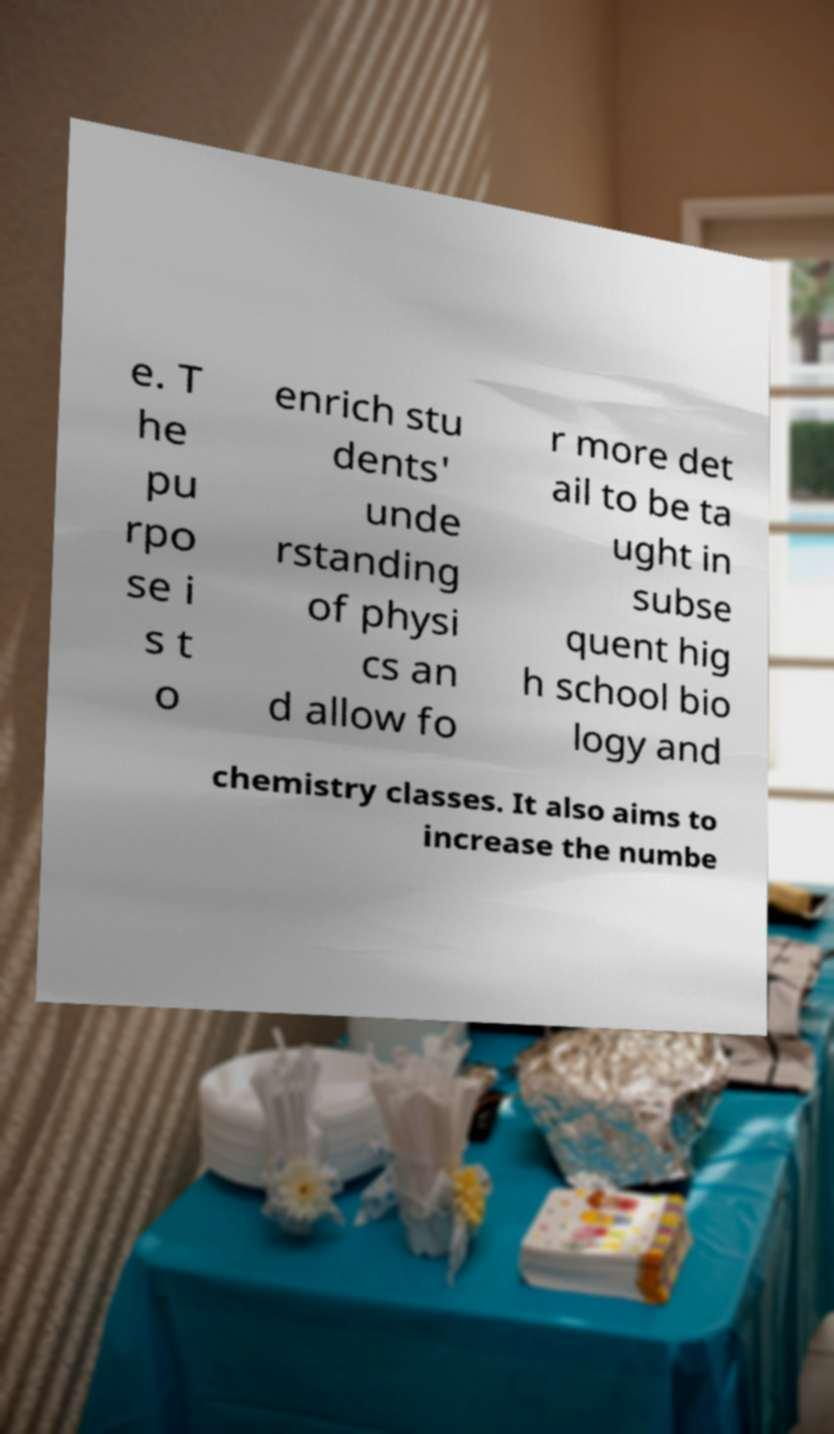Please read and relay the text visible in this image. What does it say? e. T he pu rpo se i s t o enrich stu dents' unde rstanding of physi cs an d allow fo r more det ail to be ta ught in subse quent hig h school bio logy and chemistry classes. It also aims to increase the numbe 